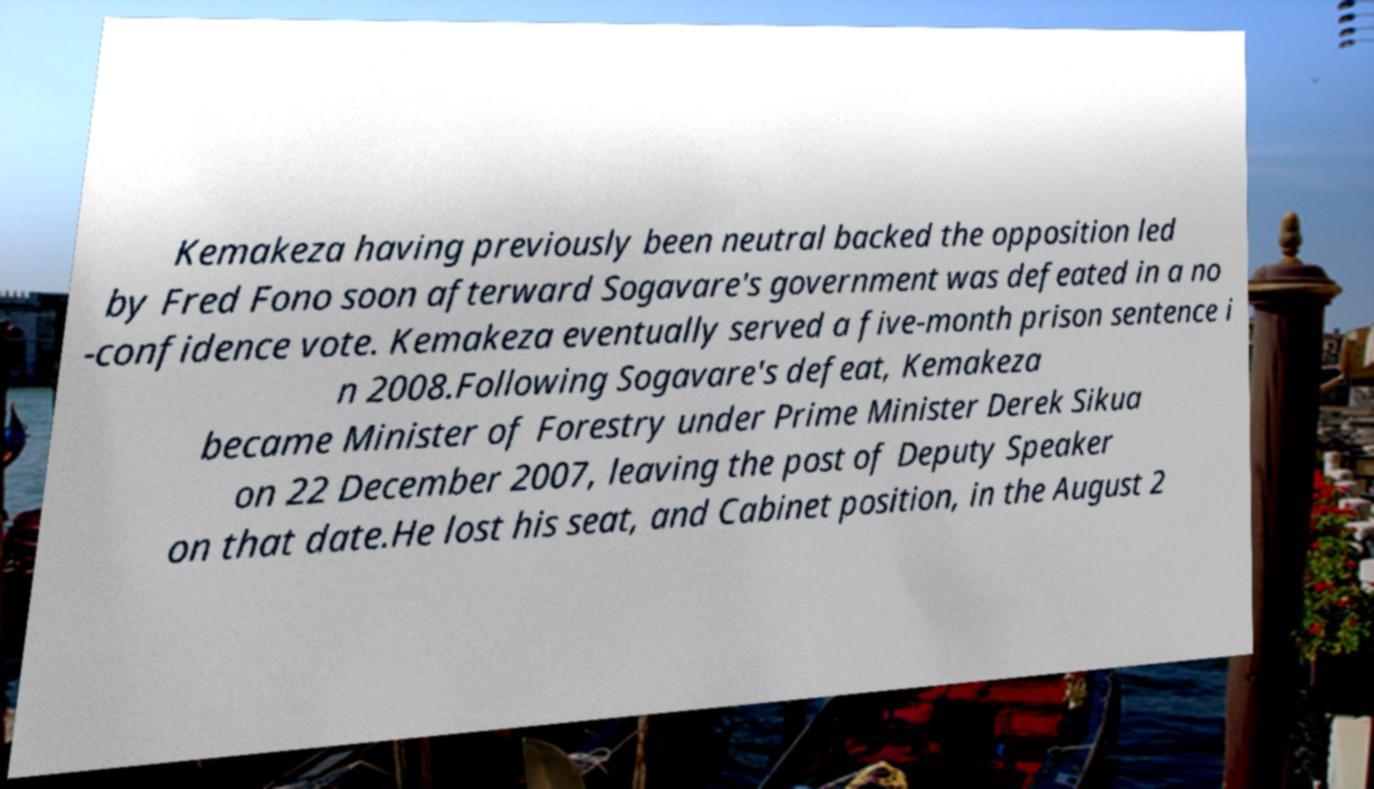Can you accurately transcribe the text from the provided image for me? Kemakeza having previously been neutral backed the opposition led by Fred Fono soon afterward Sogavare's government was defeated in a no -confidence vote. Kemakeza eventually served a five-month prison sentence i n 2008.Following Sogavare's defeat, Kemakeza became Minister of Forestry under Prime Minister Derek Sikua on 22 December 2007, leaving the post of Deputy Speaker on that date.He lost his seat, and Cabinet position, in the August 2 